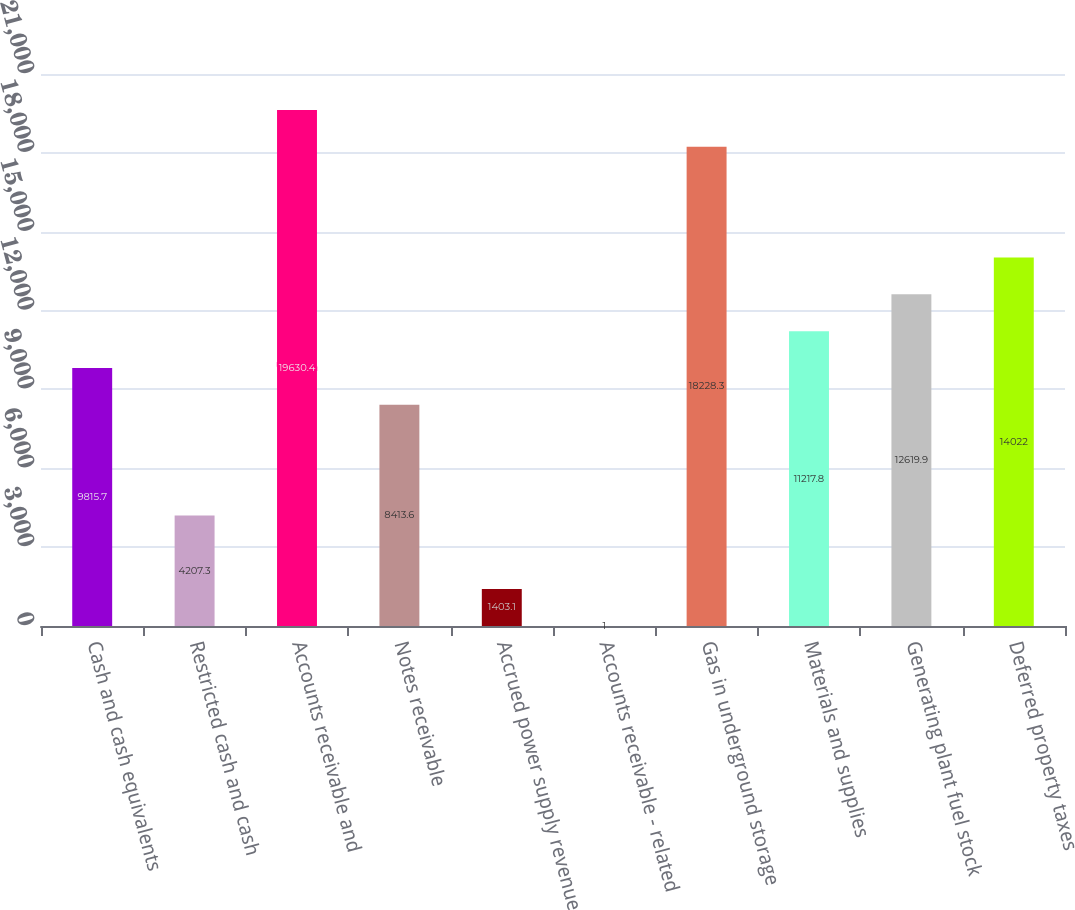Convert chart to OTSL. <chart><loc_0><loc_0><loc_500><loc_500><bar_chart><fcel>Cash and cash equivalents<fcel>Restricted cash and cash<fcel>Accounts receivable and<fcel>Notes receivable<fcel>Accrued power supply revenue<fcel>Accounts receivable - related<fcel>Gas in underground storage<fcel>Materials and supplies<fcel>Generating plant fuel stock<fcel>Deferred property taxes<nl><fcel>9815.7<fcel>4207.3<fcel>19630.4<fcel>8413.6<fcel>1403.1<fcel>1<fcel>18228.3<fcel>11217.8<fcel>12619.9<fcel>14022<nl></chart> 